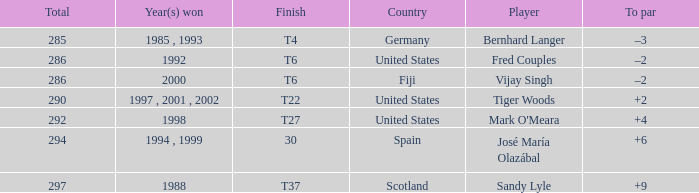Which country has a finish of t22? United States. 